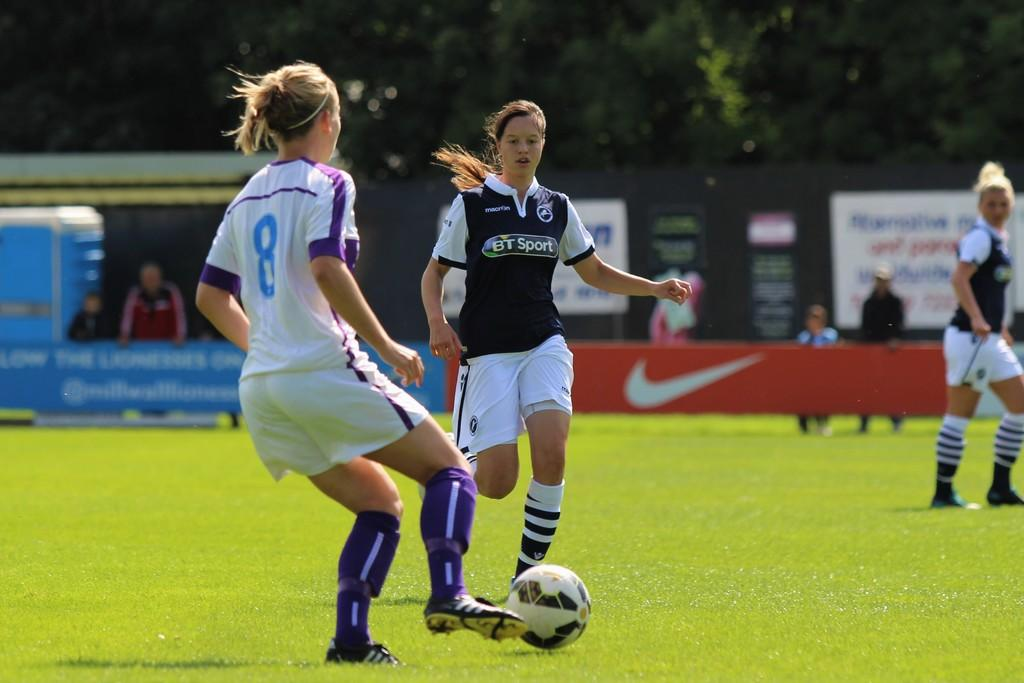<image>
Render a clear and concise summary of the photo. A group of girls playing soccer with on wearing the number 8, and the other wearing a jersey stating BT Sport. 